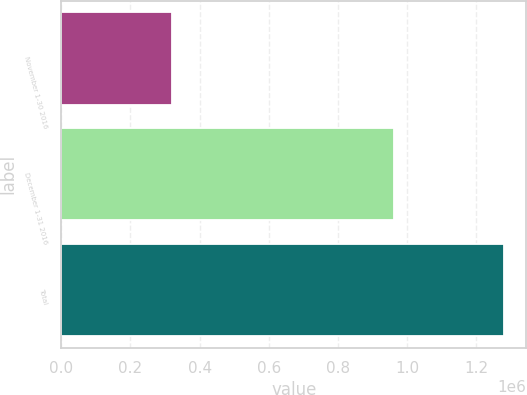Convert chart. <chart><loc_0><loc_0><loc_500><loc_500><bar_chart><fcel>November 1-30 2016<fcel>December 1-31 2016<fcel>Total<nl><fcel>320106<fcel>960619<fcel>1.28072e+06<nl></chart> 